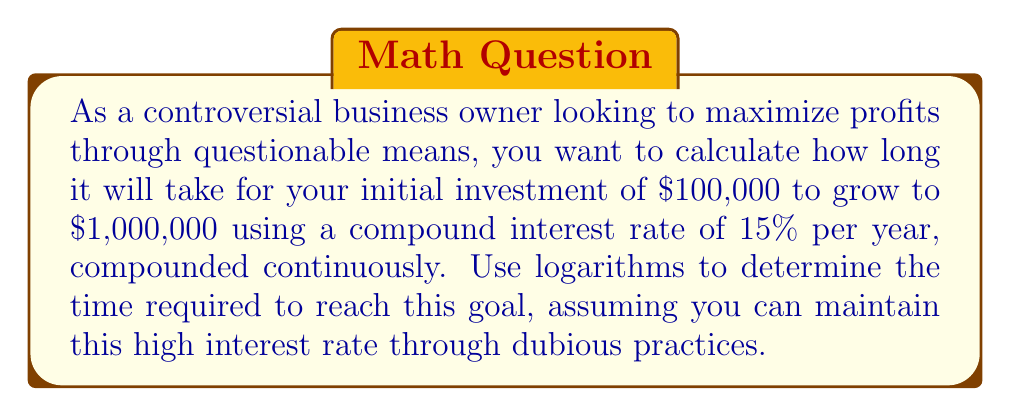Solve this math problem. To solve this problem, we'll use the continuous compound interest formula and logarithms:

$$A = P e^{rt}$$

Where:
$A$ = final amount
$P$ = principal (initial investment)
$r$ = interest rate (as a decimal)
$t$ = time in years
$e$ = Euler's number (approximately 2.71828)

Given:
$A = \$1,000,000$
$P = \$100,000$
$r = 0.15$ (15% as a decimal)

We need to solve for $t$.

Step 1: Substitute the known values into the formula:
$$1,000,000 = 100,000 e^{0.15t}$$

Step 2: Divide both sides by 100,000:
$$10 = e^{0.15t}$$

Step 3: Take the natural logarithm of both sides:
$$\ln(10) = \ln(e^{0.15t})$$

Step 4: Simplify the right side using the logarithm property $\ln(e^x) = x$:
$$\ln(10) = 0.15t$$

Step 5: Solve for $t$ by dividing both sides by 0.15:
$$t = \frac{\ln(10)}{0.15}$$

Step 6: Calculate the final result:
$$t \approx 15.33 \text{ years}$$
Answer: $15.33$ years 